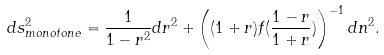Convert formula to latex. <formula><loc_0><loc_0><loc_500><loc_500>d s _ { m o n o t o n e } ^ { 2 } = \frac { 1 } { 1 - r ^ { 2 } } d r ^ { 2 } + \left ( ( 1 + r ) f ( \frac { 1 - r } { 1 + r } ) \right ) ^ { - 1 } d n ^ { 2 } .</formula> 